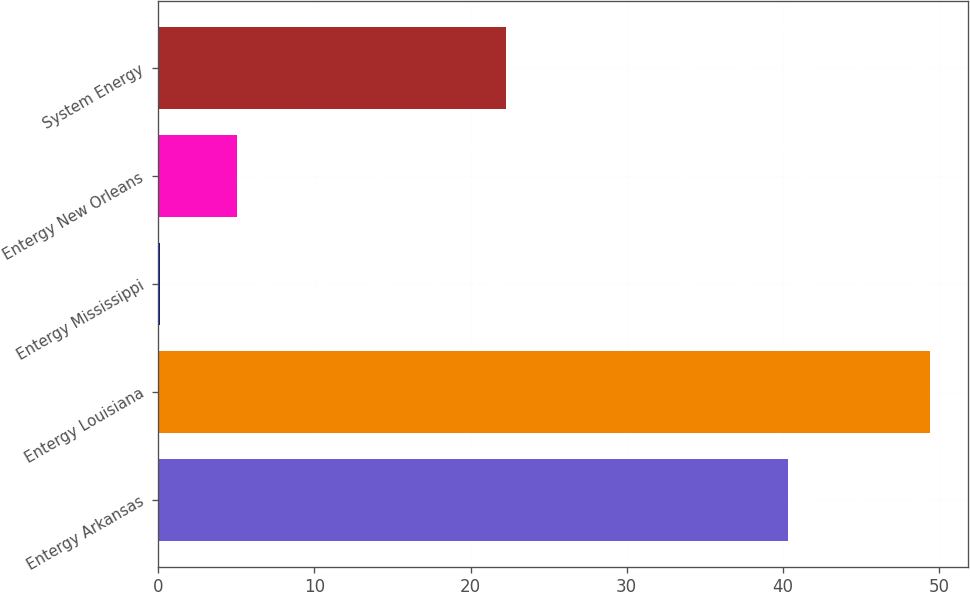<chart> <loc_0><loc_0><loc_500><loc_500><bar_chart><fcel>Entergy Arkansas<fcel>Entergy Louisiana<fcel>Entergy Mississippi<fcel>Entergy New Orleans<fcel>System Energy<nl><fcel>40.3<fcel>49.4<fcel>0.11<fcel>5.04<fcel>22.3<nl></chart> 